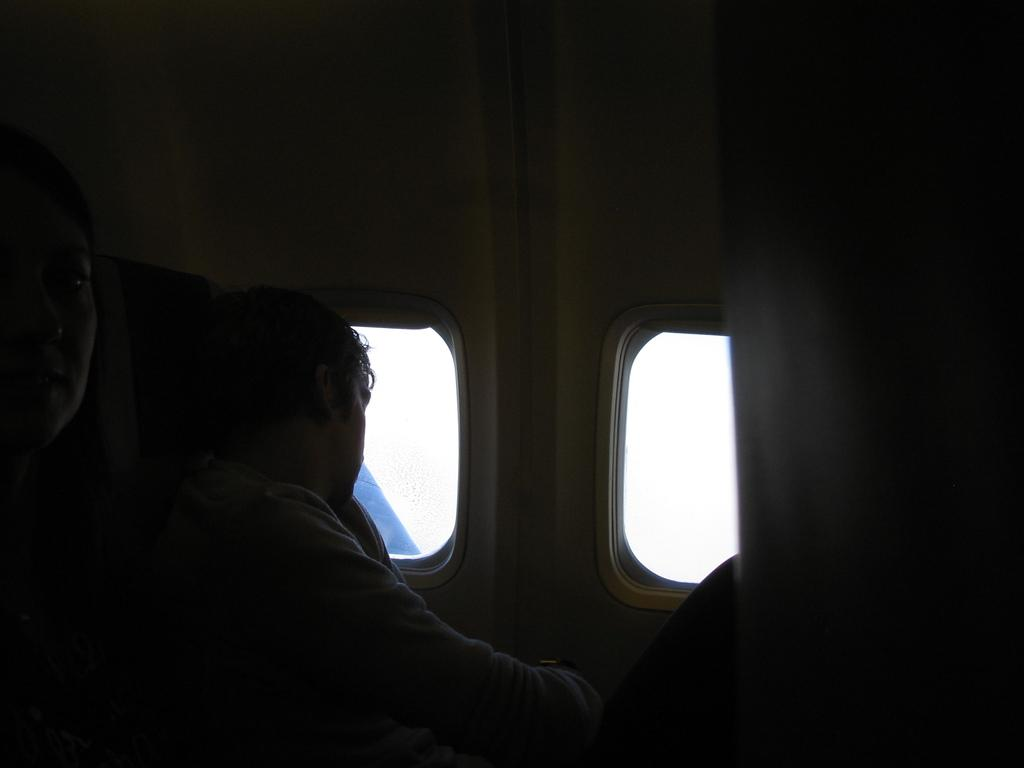Who is present in the image? There is a person in the image. What is the person doing in the image? The person is viewing outside. Where is the person located in the image? The person is inside an airplane. How is the person viewing outside? The person is looking through a window. What type of sheep can be seen playing during recess in the image? There are no sheep or recess present in the image; it features a person inside an airplane looking through a window. 